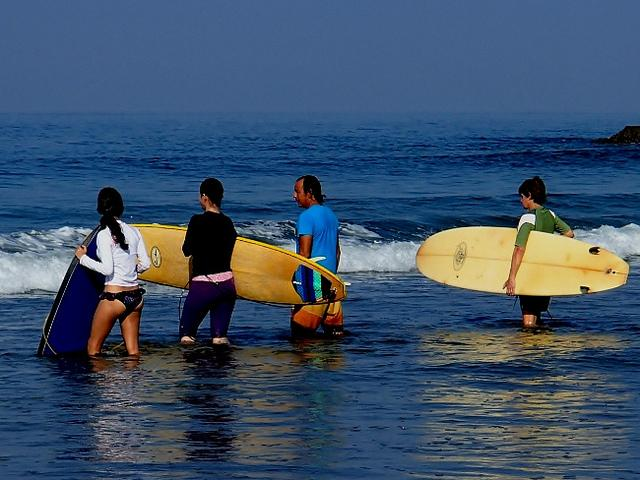What type of surfboard does the woman with the black pants have?

Choices:
A) fish
B) gun
C) shortboard
D) hybrid gun 